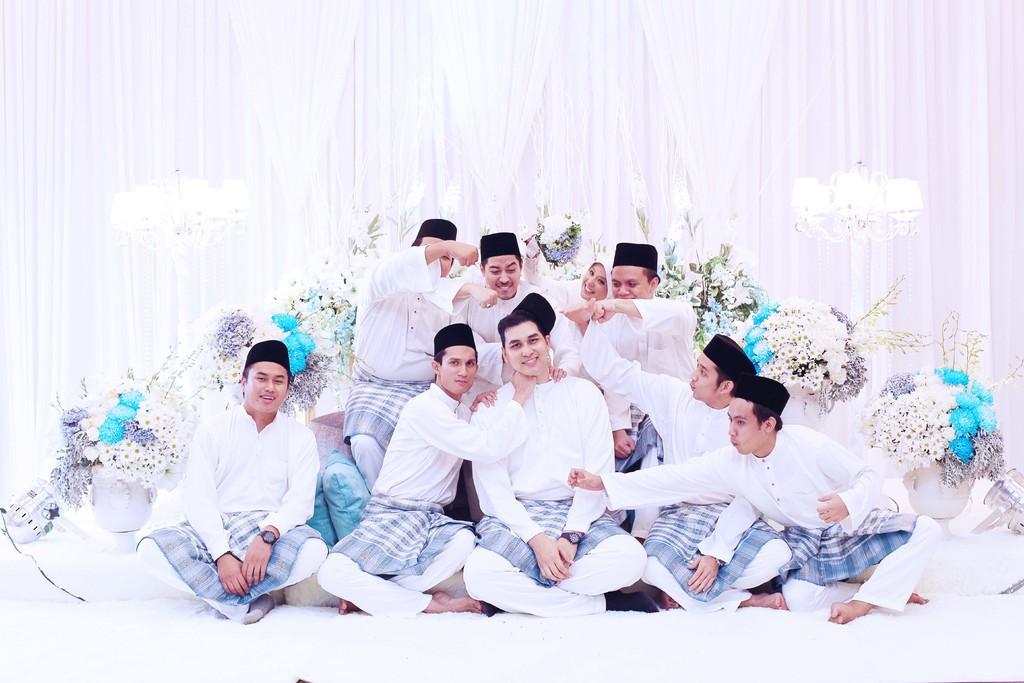In one or two sentences, can you explain what this image depicts? In this image there are a few people sitting on the floor and on the sofa, behind them there are flower pots, lamps and curtains. 